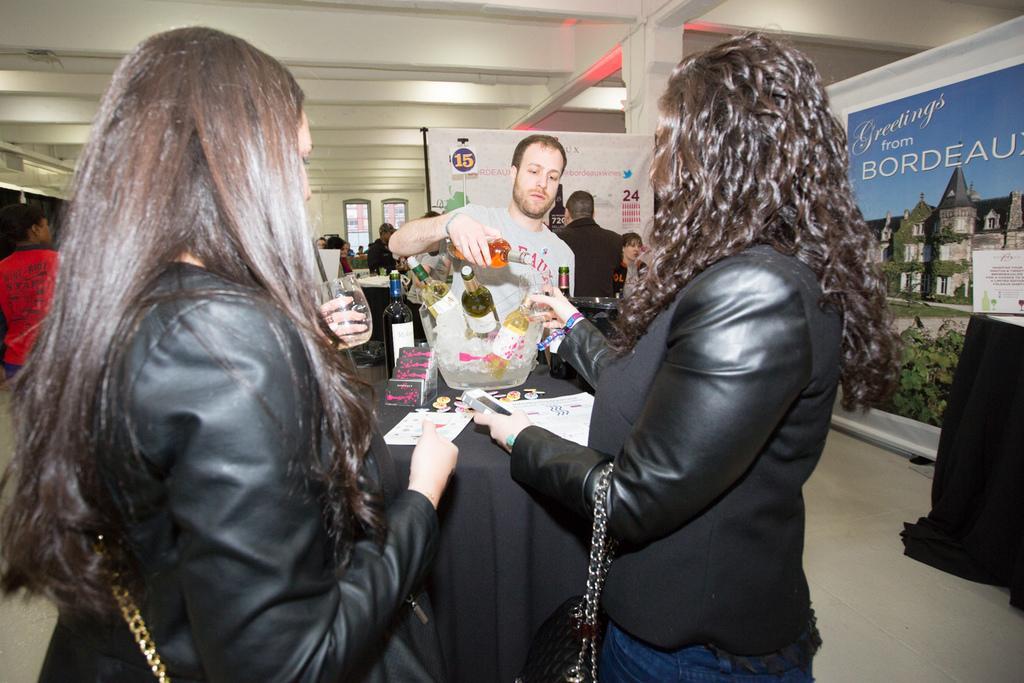Please provide a concise description of this image. In the middle of the image few people are standing and holding some glasses and bottles. Behind them there is a table, on the table there are some papers, bottles and banners. At the top of the image there is ceiling. 